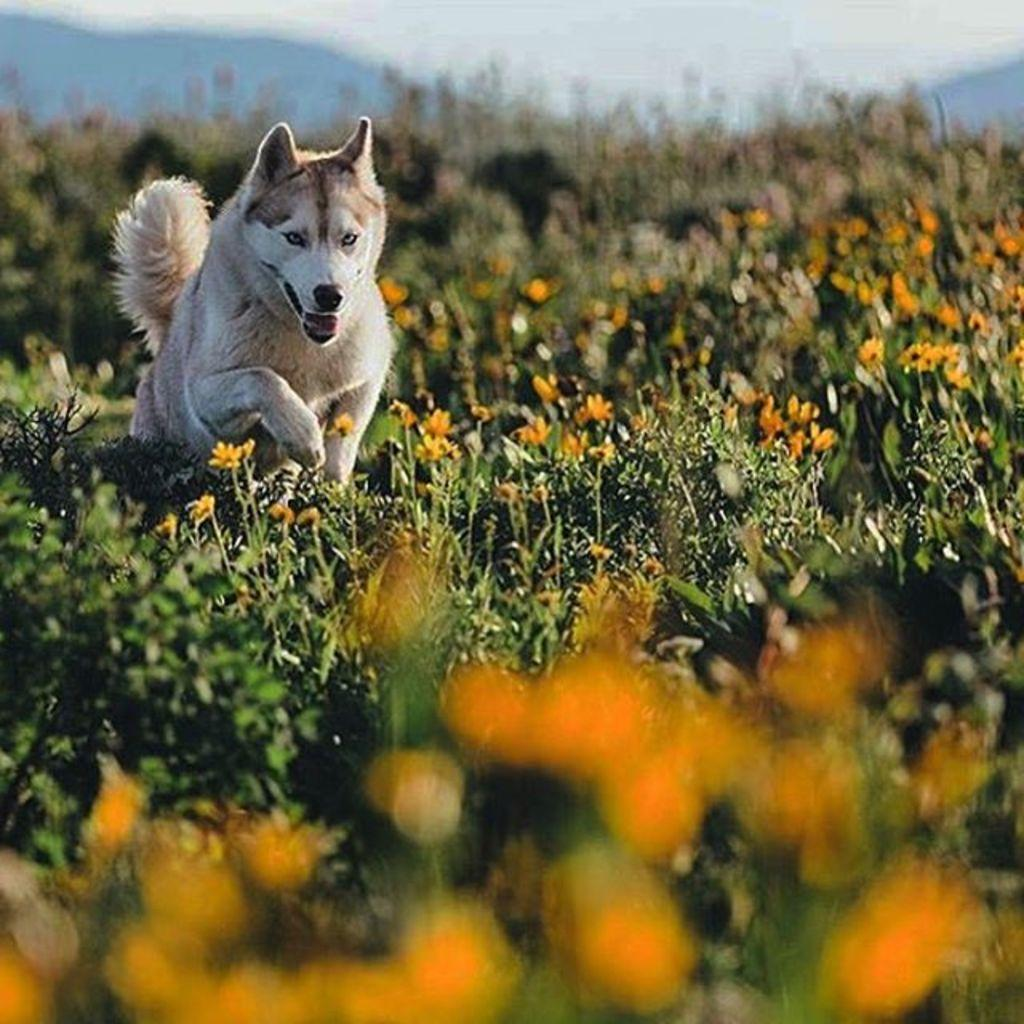What type of outdoor space is depicted in the image? There is a garden in the image. What can be found within the garden? The garden contains many flowers. Are there any animals present in the garden? Yes, there is a dog in the garden. How many chairs are placed in the garden in the image? There is no mention of chairs in the image; it features a garden with flowers and a dog. What type of fruit is the dog holding in its mouth in the image? There is no fruit, including bananas, present in the image. 